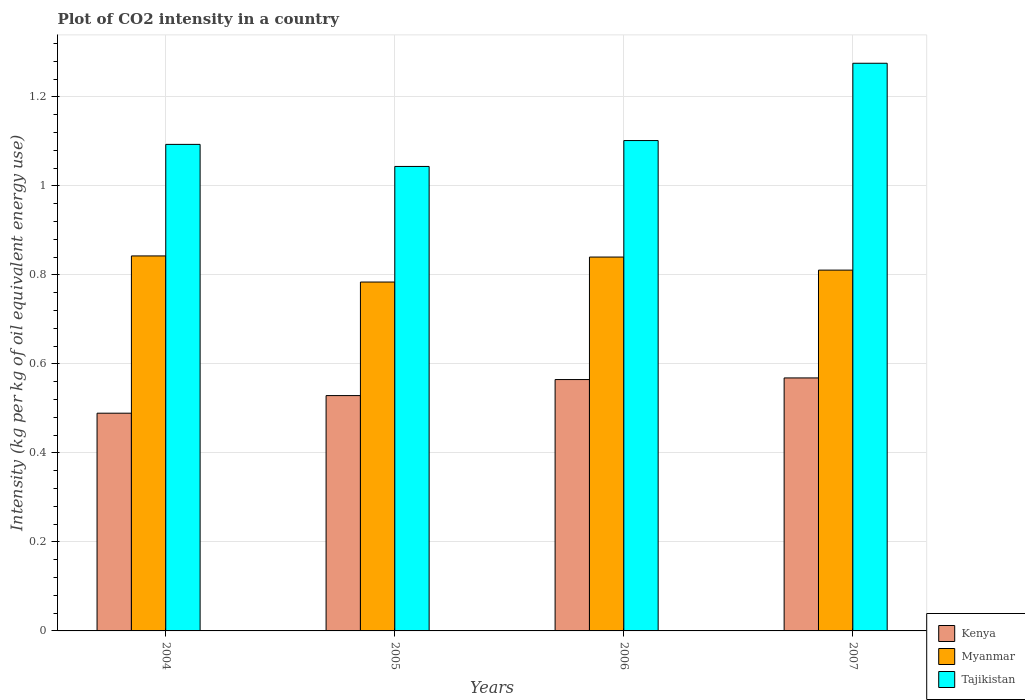How many different coloured bars are there?
Give a very brief answer. 3. How many groups of bars are there?
Make the answer very short. 4. Are the number of bars per tick equal to the number of legend labels?
Provide a succinct answer. Yes. Are the number of bars on each tick of the X-axis equal?
Keep it short and to the point. Yes. What is the CO2 intensity in in Kenya in 2005?
Give a very brief answer. 0.53. Across all years, what is the maximum CO2 intensity in in Kenya?
Provide a short and direct response. 0.57. Across all years, what is the minimum CO2 intensity in in Kenya?
Your answer should be compact. 0.49. In which year was the CO2 intensity in in Kenya maximum?
Ensure brevity in your answer.  2007. What is the total CO2 intensity in in Tajikistan in the graph?
Your answer should be very brief. 4.51. What is the difference between the CO2 intensity in in Tajikistan in 2005 and that in 2007?
Give a very brief answer. -0.23. What is the difference between the CO2 intensity in in Kenya in 2007 and the CO2 intensity in in Myanmar in 2005?
Your response must be concise. -0.22. What is the average CO2 intensity in in Myanmar per year?
Offer a terse response. 0.82. In the year 2005, what is the difference between the CO2 intensity in in Tajikistan and CO2 intensity in in Kenya?
Offer a very short reply. 0.51. What is the ratio of the CO2 intensity in in Kenya in 2004 to that in 2005?
Give a very brief answer. 0.93. What is the difference between the highest and the second highest CO2 intensity in in Tajikistan?
Your answer should be compact. 0.17. What is the difference between the highest and the lowest CO2 intensity in in Kenya?
Provide a short and direct response. 0.08. In how many years, is the CO2 intensity in in Kenya greater than the average CO2 intensity in in Kenya taken over all years?
Your answer should be compact. 2. What does the 3rd bar from the left in 2006 represents?
Offer a terse response. Tajikistan. What does the 3rd bar from the right in 2007 represents?
Give a very brief answer. Kenya. Is it the case that in every year, the sum of the CO2 intensity in in Tajikistan and CO2 intensity in in Kenya is greater than the CO2 intensity in in Myanmar?
Your answer should be compact. Yes. How many years are there in the graph?
Provide a succinct answer. 4. Are the values on the major ticks of Y-axis written in scientific E-notation?
Your response must be concise. No. Does the graph contain any zero values?
Make the answer very short. No. How are the legend labels stacked?
Ensure brevity in your answer.  Vertical. What is the title of the graph?
Offer a very short reply. Plot of CO2 intensity in a country. Does "Latvia" appear as one of the legend labels in the graph?
Keep it short and to the point. No. What is the label or title of the Y-axis?
Ensure brevity in your answer.  Intensity (kg per kg of oil equivalent energy use). What is the Intensity (kg per kg of oil equivalent energy use) of Kenya in 2004?
Your answer should be compact. 0.49. What is the Intensity (kg per kg of oil equivalent energy use) of Myanmar in 2004?
Provide a succinct answer. 0.84. What is the Intensity (kg per kg of oil equivalent energy use) in Tajikistan in 2004?
Offer a very short reply. 1.09. What is the Intensity (kg per kg of oil equivalent energy use) of Kenya in 2005?
Keep it short and to the point. 0.53. What is the Intensity (kg per kg of oil equivalent energy use) in Myanmar in 2005?
Your answer should be very brief. 0.78. What is the Intensity (kg per kg of oil equivalent energy use) in Tajikistan in 2005?
Provide a succinct answer. 1.04. What is the Intensity (kg per kg of oil equivalent energy use) of Kenya in 2006?
Your answer should be compact. 0.56. What is the Intensity (kg per kg of oil equivalent energy use) in Myanmar in 2006?
Ensure brevity in your answer.  0.84. What is the Intensity (kg per kg of oil equivalent energy use) of Tajikistan in 2006?
Give a very brief answer. 1.1. What is the Intensity (kg per kg of oil equivalent energy use) in Kenya in 2007?
Your response must be concise. 0.57. What is the Intensity (kg per kg of oil equivalent energy use) of Myanmar in 2007?
Ensure brevity in your answer.  0.81. What is the Intensity (kg per kg of oil equivalent energy use) in Tajikistan in 2007?
Ensure brevity in your answer.  1.28. Across all years, what is the maximum Intensity (kg per kg of oil equivalent energy use) of Kenya?
Offer a terse response. 0.57. Across all years, what is the maximum Intensity (kg per kg of oil equivalent energy use) of Myanmar?
Make the answer very short. 0.84. Across all years, what is the maximum Intensity (kg per kg of oil equivalent energy use) in Tajikistan?
Give a very brief answer. 1.28. Across all years, what is the minimum Intensity (kg per kg of oil equivalent energy use) of Kenya?
Offer a terse response. 0.49. Across all years, what is the minimum Intensity (kg per kg of oil equivalent energy use) in Myanmar?
Ensure brevity in your answer.  0.78. Across all years, what is the minimum Intensity (kg per kg of oil equivalent energy use) of Tajikistan?
Ensure brevity in your answer.  1.04. What is the total Intensity (kg per kg of oil equivalent energy use) of Kenya in the graph?
Your answer should be very brief. 2.15. What is the total Intensity (kg per kg of oil equivalent energy use) of Myanmar in the graph?
Your response must be concise. 3.28. What is the total Intensity (kg per kg of oil equivalent energy use) in Tajikistan in the graph?
Make the answer very short. 4.51. What is the difference between the Intensity (kg per kg of oil equivalent energy use) in Kenya in 2004 and that in 2005?
Ensure brevity in your answer.  -0.04. What is the difference between the Intensity (kg per kg of oil equivalent energy use) in Myanmar in 2004 and that in 2005?
Your answer should be compact. 0.06. What is the difference between the Intensity (kg per kg of oil equivalent energy use) in Tajikistan in 2004 and that in 2005?
Keep it short and to the point. 0.05. What is the difference between the Intensity (kg per kg of oil equivalent energy use) in Kenya in 2004 and that in 2006?
Make the answer very short. -0.08. What is the difference between the Intensity (kg per kg of oil equivalent energy use) in Myanmar in 2004 and that in 2006?
Your response must be concise. 0. What is the difference between the Intensity (kg per kg of oil equivalent energy use) of Tajikistan in 2004 and that in 2006?
Keep it short and to the point. -0.01. What is the difference between the Intensity (kg per kg of oil equivalent energy use) of Kenya in 2004 and that in 2007?
Your response must be concise. -0.08. What is the difference between the Intensity (kg per kg of oil equivalent energy use) of Myanmar in 2004 and that in 2007?
Ensure brevity in your answer.  0.03. What is the difference between the Intensity (kg per kg of oil equivalent energy use) in Tajikistan in 2004 and that in 2007?
Provide a succinct answer. -0.18. What is the difference between the Intensity (kg per kg of oil equivalent energy use) of Kenya in 2005 and that in 2006?
Your response must be concise. -0.04. What is the difference between the Intensity (kg per kg of oil equivalent energy use) of Myanmar in 2005 and that in 2006?
Give a very brief answer. -0.06. What is the difference between the Intensity (kg per kg of oil equivalent energy use) of Tajikistan in 2005 and that in 2006?
Offer a very short reply. -0.06. What is the difference between the Intensity (kg per kg of oil equivalent energy use) in Kenya in 2005 and that in 2007?
Ensure brevity in your answer.  -0.04. What is the difference between the Intensity (kg per kg of oil equivalent energy use) of Myanmar in 2005 and that in 2007?
Ensure brevity in your answer.  -0.03. What is the difference between the Intensity (kg per kg of oil equivalent energy use) of Tajikistan in 2005 and that in 2007?
Provide a succinct answer. -0.23. What is the difference between the Intensity (kg per kg of oil equivalent energy use) of Kenya in 2006 and that in 2007?
Keep it short and to the point. -0. What is the difference between the Intensity (kg per kg of oil equivalent energy use) in Myanmar in 2006 and that in 2007?
Keep it short and to the point. 0.03. What is the difference between the Intensity (kg per kg of oil equivalent energy use) in Tajikistan in 2006 and that in 2007?
Offer a terse response. -0.17. What is the difference between the Intensity (kg per kg of oil equivalent energy use) of Kenya in 2004 and the Intensity (kg per kg of oil equivalent energy use) of Myanmar in 2005?
Provide a succinct answer. -0.29. What is the difference between the Intensity (kg per kg of oil equivalent energy use) of Kenya in 2004 and the Intensity (kg per kg of oil equivalent energy use) of Tajikistan in 2005?
Provide a succinct answer. -0.55. What is the difference between the Intensity (kg per kg of oil equivalent energy use) of Myanmar in 2004 and the Intensity (kg per kg of oil equivalent energy use) of Tajikistan in 2005?
Give a very brief answer. -0.2. What is the difference between the Intensity (kg per kg of oil equivalent energy use) of Kenya in 2004 and the Intensity (kg per kg of oil equivalent energy use) of Myanmar in 2006?
Provide a succinct answer. -0.35. What is the difference between the Intensity (kg per kg of oil equivalent energy use) in Kenya in 2004 and the Intensity (kg per kg of oil equivalent energy use) in Tajikistan in 2006?
Your answer should be compact. -0.61. What is the difference between the Intensity (kg per kg of oil equivalent energy use) in Myanmar in 2004 and the Intensity (kg per kg of oil equivalent energy use) in Tajikistan in 2006?
Provide a short and direct response. -0.26. What is the difference between the Intensity (kg per kg of oil equivalent energy use) in Kenya in 2004 and the Intensity (kg per kg of oil equivalent energy use) in Myanmar in 2007?
Provide a short and direct response. -0.32. What is the difference between the Intensity (kg per kg of oil equivalent energy use) in Kenya in 2004 and the Intensity (kg per kg of oil equivalent energy use) in Tajikistan in 2007?
Ensure brevity in your answer.  -0.79. What is the difference between the Intensity (kg per kg of oil equivalent energy use) in Myanmar in 2004 and the Intensity (kg per kg of oil equivalent energy use) in Tajikistan in 2007?
Your answer should be very brief. -0.43. What is the difference between the Intensity (kg per kg of oil equivalent energy use) in Kenya in 2005 and the Intensity (kg per kg of oil equivalent energy use) in Myanmar in 2006?
Ensure brevity in your answer.  -0.31. What is the difference between the Intensity (kg per kg of oil equivalent energy use) in Kenya in 2005 and the Intensity (kg per kg of oil equivalent energy use) in Tajikistan in 2006?
Your response must be concise. -0.57. What is the difference between the Intensity (kg per kg of oil equivalent energy use) in Myanmar in 2005 and the Intensity (kg per kg of oil equivalent energy use) in Tajikistan in 2006?
Offer a terse response. -0.32. What is the difference between the Intensity (kg per kg of oil equivalent energy use) of Kenya in 2005 and the Intensity (kg per kg of oil equivalent energy use) of Myanmar in 2007?
Your answer should be compact. -0.28. What is the difference between the Intensity (kg per kg of oil equivalent energy use) of Kenya in 2005 and the Intensity (kg per kg of oil equivalent energy use) of Tajikistan in 2007?
Ensure brevity in your answer.  -0.75. What is the difference between the Intensity (kg per kg of oil equivalent energy use) of Myanmar in 2005 and the Intensity (kg per kg of oil equivalent energy use) of Tajikistan in 2007?
Your answer should be very brief. -0.49. What is the difference between the Intensity (kg per kg of oil equivalent energy use) of Kenya in 2006 and the Intensity (kg per kg of oil equivalent energy use) of Myanmar in 2007?
Your answer should be very brief. -0.25. What is the difference between the Intensity (kg per kg of oil equivalent energy use) in Kenya in 2006 and the Intensity (kg per kg of oil equivalent energy use) in Tajikistan in 2007?
Offer a terse response. -0.71. What is the difference between the Intensity (kg per kg of oil equivalent energy use) in Myanmar in 2006 and the Intensity (kg per kg of oil equivalent energy use) in Tajikistan in 2007?
Make the answer very short. -0.44. What is the average Intensity (kg per kg of oil equivalent energy use) of Kenya per year?
Offer a very short reply. 0.54. What is the average Intensity (kg per kg of oil equivalent energy use) in Myanmar per year?
Your answer should be very brief. 0.82. What is the average Intensity (kg per kg of oil equivalent energy use) in Tajikistan per year?
Keep it short and to the point. 1.13. In the year 2004, what is the difference between the Intensity (kg per kg of oil equivalent energy use) in Kenya and Intensity (kg per kg of oil equivalent energy use) in Myanmar?
Your answer should be very brief. -0.35. In the year 2004, what is the difference between the Intensity (kg per kg of oil equivalent energy use) of Kenya and Intensity (kg per kg of oil equivalent energy use) of Tajikistan?
Offer a very short reply. -0.6. In the year 2004, what is the difference between the Intensity (kg per kg of oil equivalent energy use) of Myanmar and Intensity (kg per kg of oil equivalent energy use) of Tajikistan?
Offer a very short reply. -0.25. In the year 2005, what is the difference between the Intensity (kg per kg of oil equivalent energy use) in Kenya and Intensity (kg per kg of oil equivalent energy use) in Myanmar?
Keep it short and to the point. -0.26. In the year 2005, what is the difference between the Intensity (kg per kg of oil equivalent energy use) in Kenya and Intensity (kg per kg of oil equivalent energy use) in Tajikistan?
Your answer should be very brief. -0.51. In the year 2005, what is the difference between the Intensity (kg per kg of oil equivalent energy use) of Myanmar and Intensity (kg per kg of oil equivalent energy use) of Tajikistan?
Provide a short and direct response. -0.26. In the year 2006, what is the difference between the Intensity (kg per kg of oil equivalent energy use) in Kenya and Intensity (kg per kg of oil equivalent energy use) in Myanmar?
Keep it short and to the point. -0.28. In the year 2006, what is the difference between the Intensity (kg per kg of oil equivalent energy use) in Kenya and Intensity (kg per kg of oil equivalent energy use) in Tajikistan?
Offer a terse response. -0.54. In the year 2006, what is the difference between the Intensity (kg per kg of oil equivalent energy use) of Myanmar and Intensity (kg per kg of oil equivalent energy use) of Tajikistan?
Ensure brevity in your answer.  -0.26. In the year 2007, what is the difference between the Intensity (kg per kg of oil equivalent energy use) of Kenya and Intensity (kg per kg of oil equivalent energy use) of Myanmar?
Ensure brevity in your answer.  -0.24. In the year 2007, what is the difference between the Intensity (kg per kg of oil equivalent energy use) of Kenya and Intensity (kg per kg of oil equivalent energy use) of Tajikistan?
Give a very brief answer. -0.71. In the year 2007, what is the difference between the Intensity (kg per kg of oil equivalent energy use) in Myanmar and Intensity (kg per kg of oil equivalent energy use) in Tajikistan?
Provide a short and direct response. -0.46. What is the ratio of the Intensity (kg per kg of oil equivalent energy use) of Kenya in 2004 to that in 2005?
Offer a terse response. 0.93. What is the ratio of the Intensity (kg per kg of oil equivalent energy use) of Myanmar in 2004 to that in 2005?
Your answer should be compact. 1.07. What is the ratio of the Intensity (kg per kg of oil equivalent energy use) of Tajikistan in 2004 to that in 2005?
Provide a short and direct response. 1.05. What is the ratio of the Intensity (kg per kg of oil equivalent energy use) in Kenya in 2004 to that in 2006?
Provide a short and direct response. 0.87. What is the ratio of the Intensity (kg per kg of oil equivalent energy use) of Kenya in 2004 to that in 2007?
Provide a short and direct response. 0.86. What is the ratio of the Intensity (kg per kg of oil equivalent energy use) in Myanmar in 2004 to that in 2007?
Keep it short and to the point. 1.04. What is the ratio of the Intensity (kg per kg of oil equivalent energy use) in Kenya in 2005 to that in 2006?
Make the answer very short. 0.94. What is the ratio of the Intensity (kg per kg of oil equivalent energy use) of Myanmar in 2005 to that in 2006?
Offer a very short reply. 0.93. What is the ratio of the Intensity (kg per kg of oil equivalent energy use) in Tajikistan in 2005 to that in 2006?
Give a very brief answer. 0.95. What is the ratio of the Intensity (kg per kg of oil equivalent energy use) of Kenya in 2005 to that in 2007?
Offer a terse response. 0.93. What is the ratio of the Intensity (kg per kg of oil equivalent energy use) in Myanmar in 2005 to that in 2007?
Offer a very short reply. 0.97. What is the ratio of the Intensity (kg per kg of oil equivalent energy use) in Tajikistan in 2005 to that in 2007?
Offer a terse response. 0.82. What is the ratio of the Intensity (kg per kg of oil equivalent energy use) of Myanmar in 2006 to that in 2007?
Provide a succinct answer. 1.04. What is the ratio of the Intensity (kg per kg of oil equivalent energy use) in Tajikistan in 2006 to that in 2007?
Make the answer very short. 0.86. What is the difference between the highest and the second highest Intensity (kg per kg of oil equivalent energy use) in Kenya?
Offer a very short reply. 0. What is the difference between the highest and the second highest Intensity (kg per kg of oil equivalent energy use) of Myanmar?
Offer a terse response. 0. What is the difference between the highest and the second highest Intensity (kg per kg of oil equivalent energy use) of Tajikistan?
Offer a very short reply. 0.17. What is the difference between the highest and the lowest Intensity (kg per kg of oil equivalent energy use) of Kenya?
Your response must be concise. 0.08. What is the difference between the highest and the lowest Intensity (kg per kg of oil equivalent energy use) in Myanmar?
Your answer should be very brief. 0.06. What is the difference between the highest and the lowest Intensity (kg per kg of oil equivalent energy use) in Tajikistan?
Your answer should be very brief. 0.23. 